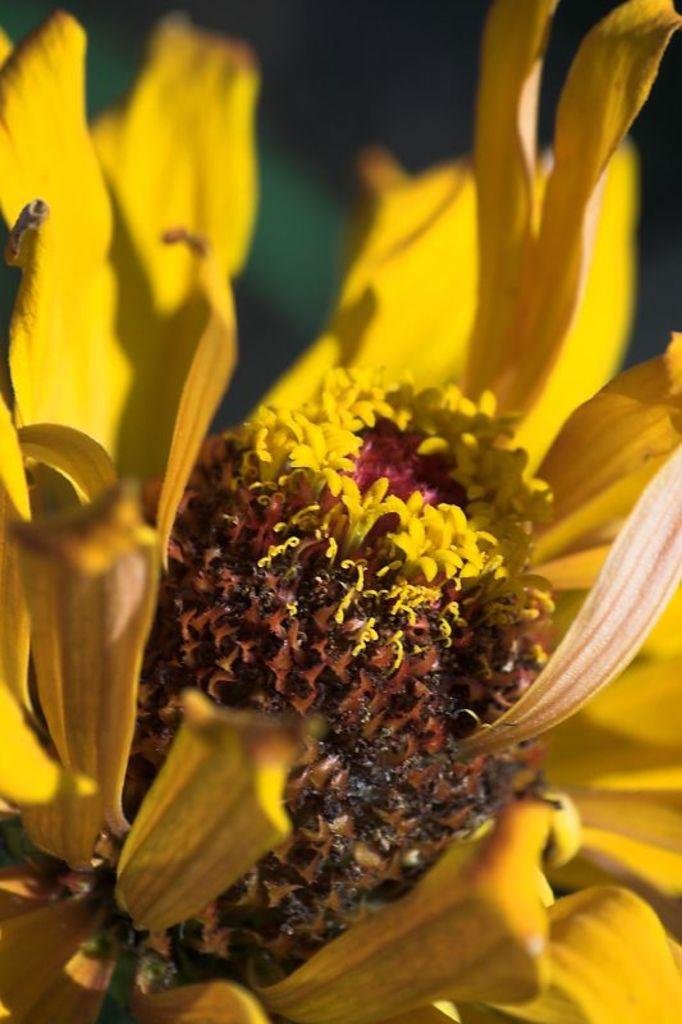What is the focus of the image? The image is a zoomed-in picture of a yellow color flower. Can you describe the color of the flower in the image? The flower in the image is yellow. How many matches are needed to light the flower in the image? There are no matches present in the image, and the flower is not on fire. 